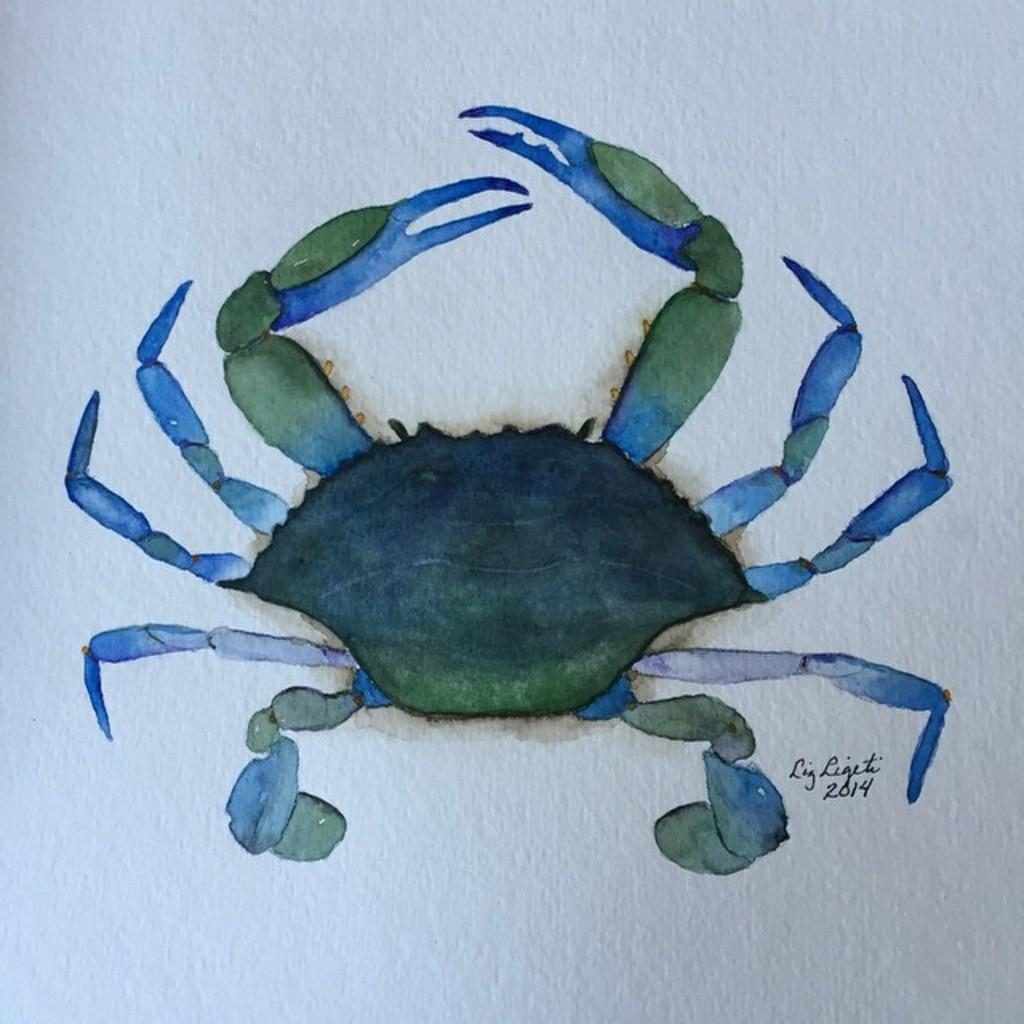What is depicted on the paper in the image? There is a sketch of a crab on the paper. What else can be seen in the image besides the sketch of the crab? There is text in the image. What type of dock can be seen in the image? There is no dock present in the image. How many volleyballs are visible in the image? There are no volleyballs present in the image. 